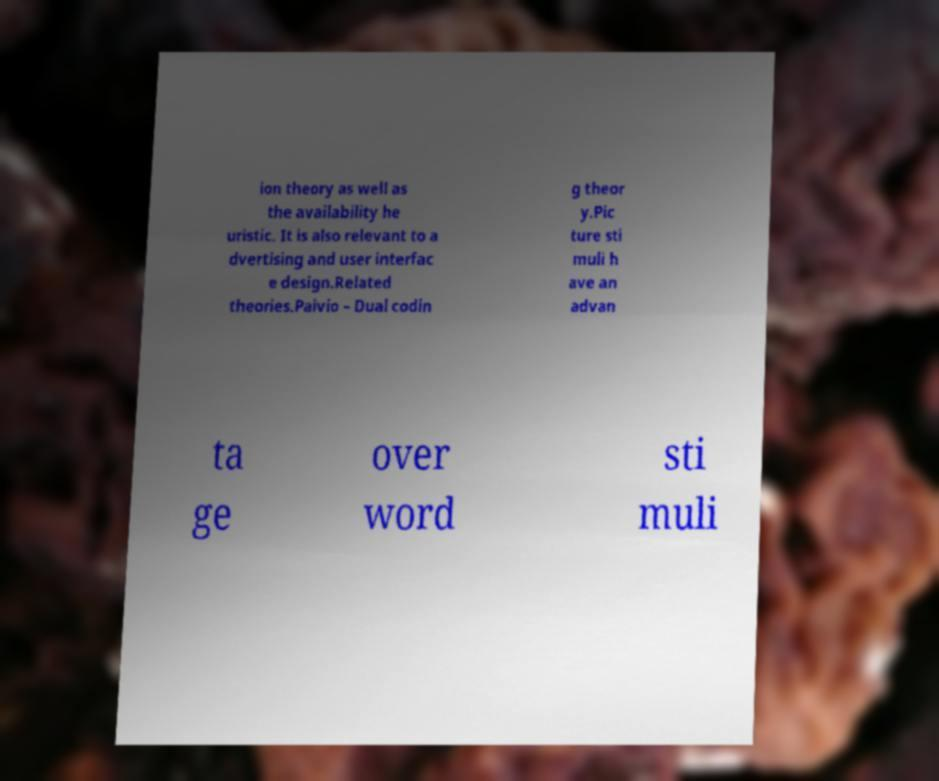Could you assist in decoding the text presented in this image and type it out clearly? ion theory as well as the availability he uristic. It is also relevant to a dvertising and user interfac e design.Related theories.Paivio – Dual codin g theor y.Pic ture sti muli h ave an advan ta ge over word sti muli 